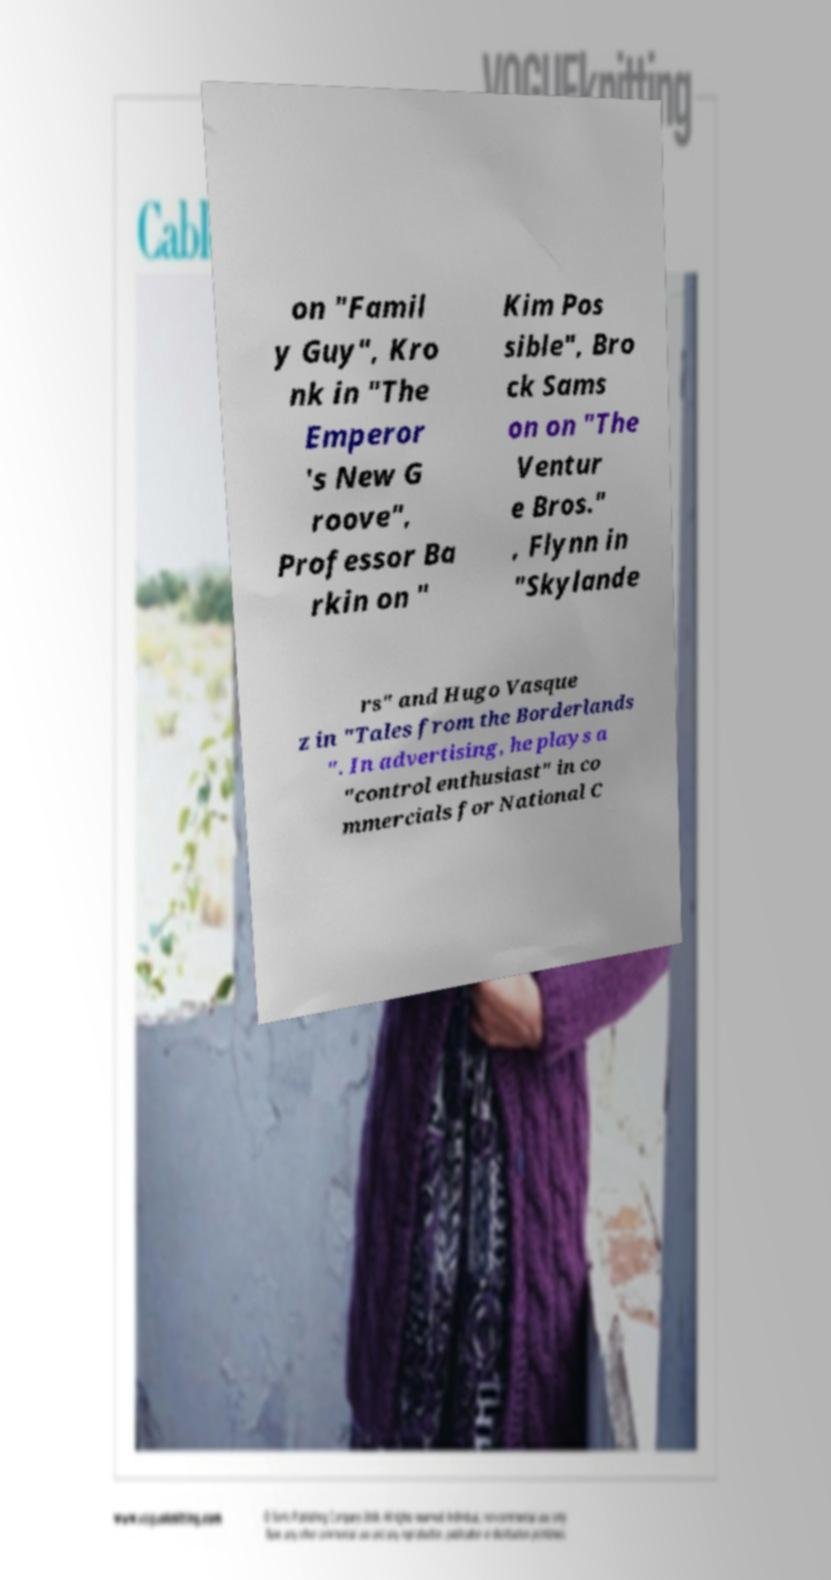Can you read and provide the text displayed in the image?This photo seems to have some interesting text. Can you extract and type it out for me? on "Famil y Guy", Kro nk in "The Emperor 's New G roove", Professor Ba rkin on " Kim Pos sible", Bro ck Sams on on "The Ventur e Bros." , Flynn in "Skylande rs" and Hugo Vasque z in "Tales from the Borderlands ". In advertising, he plays a "control enthusiast" in co mmercials for National C 